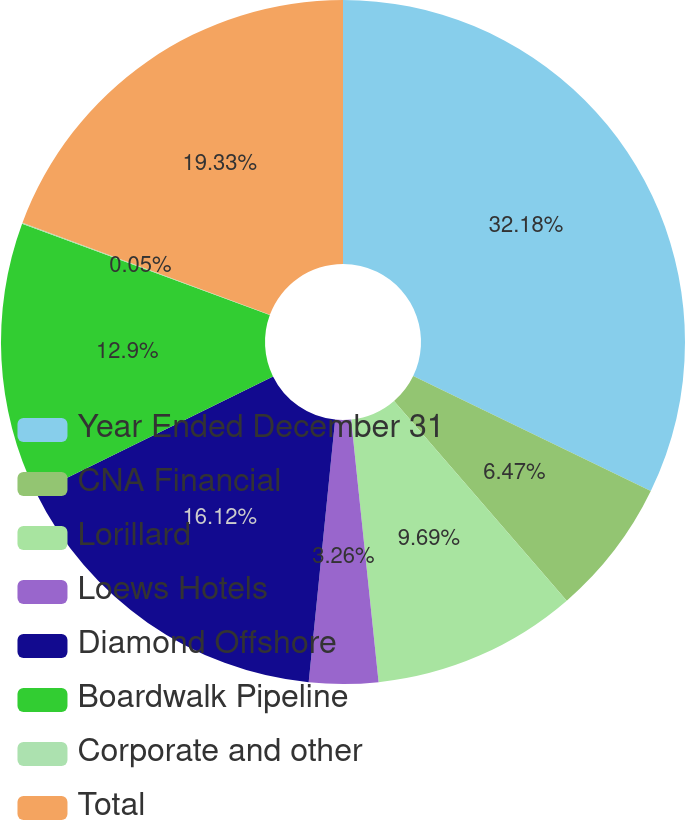Convert chart. <chart><loc_0><loc_0><loc_500><loc_500><pie_chart><fcel>Year Ended December 31<fcel>CNA Financial<fcel>Lorillard<fcel>Loews Hotels<fcel>Diamond Offshore<fcel>Boardwalk Pipeline<fcel>Corporate and other<fcel>Total<nl><fcel>32.18%<fcel>6.47%<fcel>9.69%<fcel>3.26%<fcel>16.12%<fcel>12.9%<fcel>0.05%<fcel>19.33%<nl></chart> 